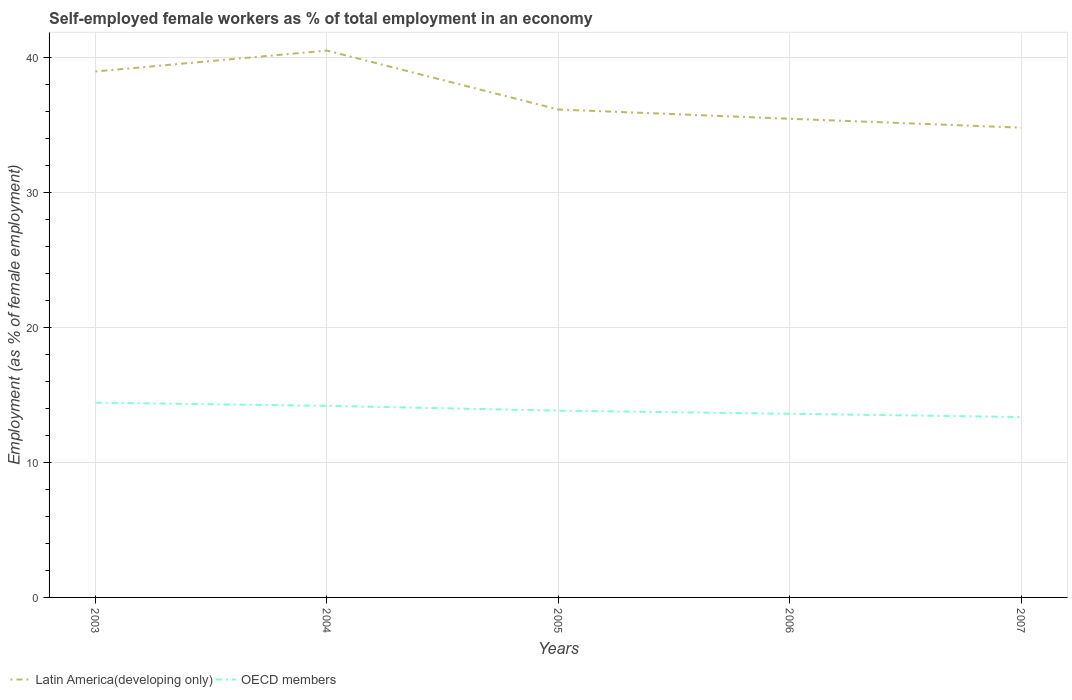How many different coloured lines are there?
Provide a short and direct response. 2. Is the number of lines equal to the number of legend labels?
Make the answer very short. Yes. Across all years, what is the maximum percentage of self-employed female workers in OECD members?
Your response must be concise. 13.38. In which year was the percentage of self-employed female workers in Latin America(developing only) maximum?
Keep it short and to the point. 2007. What is the total percentage of self-employed female workers in Latin America(developing only) in the graph?
Provide a short and direct response. 0.69. What is the difference between the highest and the second highest percentage of self-employed female workers in Latin America(developing only)?
Make the answer very short. 5.72. What is the difference between the highest and the lowest percentage of self-employed female workers in OECD members?
Ensure brevity in your answer.  2. How many years are there in the graph?
Your answer should be very brief. 5. What is the difference between two consecutive major ticks on the Y-axis?
Ensure brevity in your answer.  10. Are the values on the major ticks of Y-axis written in scientific E-notation?
Keep it short and to the point. No. Does the graph contain any zero values?
Your response must be concise. No. Where does the legend appear in the graph?
Ensure brevity in your answer.  Bottom left. How are the legend labels stacked?
Make the answer very short. Horizontal. What is the title of the graph?
Ensure brevity in your answer.  Self-employed female workers as % of total employment in an economy. Does "Sub-Saharan Africa (developing only)" appear as one of the legend labels in the graph?
Ensure brevity in your answer.  No. What is the label or title of the Y-axis?
Your answer should be compact. Employment (as % of female employment). What is the Employment (as % of female employment) in Latin America(developing only) in 2003?
Ensure brevity in your answer.  39. What is the Employment (as % of female employment) of OECD members in 2003?
Provide a short and direct response. 14.44. What is the Employment (as % of female employment) of Latin America(developing only) in 2004?
Your response must be concise. 40.55. What is the Employment (as % of female employment) in OECD members in 2004?
Give a very brief answer. 14.21. What is the Employment (as % of female employment) of Latin America(developing only) in 2005?
Offer a terse response. 36.18. What is the Employment (as % of female employment) in OECD members in 2005?
Your answer should be very brief. 13.85. What is the Employment (as % of female employment) in Latin America(developing only) in 2006?
Provide a succinct answer. 35.49. What is the Employment (as % of female employment) in OECD members in 2006?
Provide a short and direct response. 13.62. What is the Employment (as % of female employment) of Latin America(developing only) in 2007?
Your answer should be compact. 34.83. What is the Employment (as % of female employment) of OECD members in 2007?
Give a very brief answer. 13.38. Across all years, what is the maximum Employment (as % of female employment) in Latin America(developing only)?
Ensure brevity in your answer.  40.55. Across all years, what is the maximum Employment (as % of female employment) in OECD members?
Keep it short and to the point. 14.44. Across all years, what is the minimum Employment (as % of female employment) in Latin America(developing only)?
Make the answer very short. 34.83. Across all years, what is the minimum Employment (as % of female employment) in OECD members?
Provide a short and direct response. 13.38. What is the total Employment (as % of female employment) in Latin America(developing only) in the graph?
Provide a succinct answer. 186.05. What is the total Employment (as % of female employment) of OECD members in the graph?
Ensure brevity in your answer.  69.5. What is the difference between the Employment (as % of female employment) of Latin America(developing only) in 2003 and that in 2004?
Your answer should be compact. -1.55. What is the difference between the Employment (as % of female employment) of OECD members in 2003 and that in 2004?
Your response must be concise. 0.24. What is the difference between the Employment (as % of female employment) in Latin America(developing only) in 2003 and that in 2005?
Make the answer very short. 2.82. What is the difference between the Employment (as % of female employment) of OECD members in 2003 and that in 2005?
Ensure brevity in your answer.  0.59. What is the difference between the Employment (as % of female employment) of Latin America(developing only) in 2003 and that in 2006?
Offer a very short reply. 3.51. What is the difference between the Employment (as % of female employment) of OECD members in 2003 and that in 2006?
Your answer should be very brief. 0.83. What is the difference between the Employment (as % of female employment) of Latin America(developing only) in 2003 and that in 2007?
Your answer should be compact. 4.17. What is the difference between the Employment (as % of female employment) of OECD members in 2003 and that in 2007?
Offer a terse response. 1.07. What is the difference between the Employment (as % of female employment) of Latin America(developing only) in 2004 and that in 2005?
Ensure brevity in your answer.  4.37. What is the difference between the Employment (as % of female employment) in OECD members in 2004 and that in 2005?
Your answer should be compact. 0.36. What is the difference between the Employment (as % of female employment) in Latin America(developing only) in 2004 and that in 2006?
Offer a very short reply. 5.06. What is the difference between the Employment (as % of female employment) of OECD members in 2004 and that in 2006?
Give a very brief answer. 0.59. What is the difference between the Employment (as % of female employment) of Latin America(developing only) in 2004 and that in 2007?
Make the answer very short. 5.72. What is the difference between the Employment (as % of female employment) of OECD members in 2004 and that in 2007?
Your answer should be very brief. 0.83. What is the difference between the Employment (as % of female employment) of Latin America(developing only) in 2005 and that in 2006?
Give a very brief answer. 0.69. What is the difference between the Employment (as % of female employment) in OECD members in 2005 and that in 2006?
Make the answer very short. 0.23. What is the difference between the Employment (as % of female employment) of Latin America(developing only) in 2005 and that in 2007?
Keep it short and to the point. 1.35. What is the difference between the Employment (as % of female employment) of OECD members in 2005 and that in 2007?
Your answer should be compact. 0.47. What is the difference between the Employment (as % of female employment) in Latin America(developing only) in 2006 and that in 2007?
Provide a short and direct response. 0.66. What is the difference between the Employment (as % of female employment) of OECD members in 2006 and that in 2007?
Your response must be concise. 0.24. What is the difference between the Employment (as % of female employment) of Latin America(developing only) in 2003 and the Employment (as % of female employment) of OECD members in 2004?
Offer a terse response. 24.79. What is the difference between the Employment (as % of female employment) of Latin America(developing only) in 2003 and the Employment (as % of female employment) of OECD members in 2005?
Offer a very short reply. 25.15. What is the difference between the Employment (as % of female employment) in Latin America(developing only) in 2003 and the Employment (as % of female employment) in OECD members in 2006?
Your answer should be compact. 25.38. What is the difference between the Employment (as % of female employment) in Latin America(developing only) in 2003 and the Employment (as % of female employment) in OECD members in 2007?
Make the answer very short. 25.62. What is the difference between the Employment (as % of female employment) of Latin America(developing only) in 2004 and the Employment (as % of female employment) of OECD members in 2005?
Give a very brief answer. 26.7. What is the difference between the Employment (as % of female employment) of Latin America(developing only) in 2004 and the Employment (as % of female employment) of OECD members in 2006?
Give a very brief answer. 26.93. What is the difference between the Employment (as % of female employment) in Latin America(developing only) in 2004 and the Employment (as % of female employment) in OECD members in 2007?
Give a very brief answer. 27.17. What is the difference between the Employment (as % of female employment) in Latin America(developing only) in 2005 and the Employment (as % of female employment) in OECD members in 2006?
Provide a short and direct response. 22.56. What is the difference between the Employment (as % of female employment) in Latin America(developing only) in 2005 and the Employment (as % of female employment) in OECD members in 2007?
Your response must be concise. 22.8. What is the difference between the Employment (as % of female employment) of Latin America(developing only) in 2006 and the Employment (as % of female employment) of OECD members in 2007?
Keep it short and to the point. 22.12. What is the average Employment (as % of female employment) in Latin America(developing only) per year?
Make the answer very short. 37.21. What is the average Employment (as % of female employment) of OECD members per year?
Make the answer very short. 13.9. In the year 2003, what is the difference between the Employment (as % of female employment) in Latin America(developing only) and Employment (as % of female employment) in OECD members?
Your response must be concise. 24.56. In the year 2004, what is the difference between the Employment (as % of female employment) in Latin America(developing only) and Employment (as % of female employment) in OECD members?
Offer a very short reply. 26.34. In the year 2005, what is the difference between the Employment (as % of female employment) in Latin America(developing only) and Employment (as % of female employment) in OECD members?
Your answer should be compact. 22.33. In the year 2006, what is the difference between the Employment (as % of female employment) in Latin America(developing only) and Employment (as % of female employment) in OECD members?
Offer a terse response. 21.87. In the year 2007, what is the difference between the Employment (as % of female employment) of Latin America(developing only) and Employment (as % of female employment) of OECD members?
Your answer should be compact. 21.46. What is the ratio of the Employment (as % of female employment) in Latin America(developing only) in 2003 to that in 2004?
Give a very brief answer. 0.96. What is the ratio of the Employment (as % of female employment) in OECD members in 2003 to that in 2004?
Provide a succinct answer. 1.02. What is the ratio of the Employment (as % of female employment) of Latin America(developing only) in 2003 to that in 2005?
Keep it short and to the point. 1.08. What is the ratio of the Employment (as % of female employment) in OECD members in 2003 to that in 2005?
Keep it short and to the point. 1.04. What is the ratio of the Employment (as % of female employment) in Latin America(developing only) in 2003 to that in 2006?
Your response must be concise. 1.1. What is the ratio of the Employment (as % of female employment) of OECD members in 2003 to that in 2006?
Provide a short and direct response. 1.06. What is the ratio of the Employment (as % of female employment) of Latin America(developing only) in 2003 to that in 2007?
Provide a succinct answer. 1.12. What is the ratio of the Employment (as % of female employment) in OECD members in 2003 to that in 2007?
Offer a very short reply. 1.08. What is the ratio of the Employment (as % of female employment) of Latin America(developing only) in 2004 to that in 2005?
Provide a short and direct response. 1.12. What is the ratio of the Employment (as % of female employment) of OECD members in 2004 to that in 2005?
Give a very brief answer. 1.03. What is the ratio of the Employment (as % of female employment) in Latin America(developing only) in 2004 to that in 2006?
Provide a succinct answer. 1.14. What is the ratio of the Employment (as % of female employment) in OECD members in 2004 to that in 2006?
Your answer should be very brief. 1.04. What is the ratio of the Employment (as % of female employment) of Latin America(developing only) in 2004 to that in 2007?
Your answer should be compact. 1.16. What is the ratio of the Employment (as % of female employment) in OECD members in 2004 to that in 2007?
Offer a very short reply. 1.06. What is the ratio of the Employment (as % of female employment) in Latin America(developing only) in 2005 to that in 2006?
Offer a terse response. 1.02. What is the ratio of the Employment (as % of female employment) of OECD members in 2005 to that in 2006?
Your answer should be very brief. 1.02. What is the ratio of the Employment (as % of female employment) in Latin America(developing only) in 2005 to that in 2007?
Provide a short and direct response. 1.04. What is the ratio of the Employment (as % of female employment) of OECD members in 2005 to that in 2007?
Ensure brevity in your answer.  1.04. What is the ratio of the Employment (as % of female employment) of OECD members in 2006 to that in 2007?
Keep it short and to the point. 1.02. What is the difference between the highest and the second highest Employment (as % of female employment) in Latin America(developing only)?
Your answer should be compact. 1.55. What is the difference between the highest and the second highest Employment (as % of female employment) in OECD members?
Your response must be concise. 0.24. What is the difference between the highest and the lowest Employment (as % of female employment) in Latin America(developing only)?
Ensure brevity in your answer.  5.72. What is the difference between the highest and the lowest Employment (as % of female employment) of OECD members?
Your answer should be very brief. 1.07. 